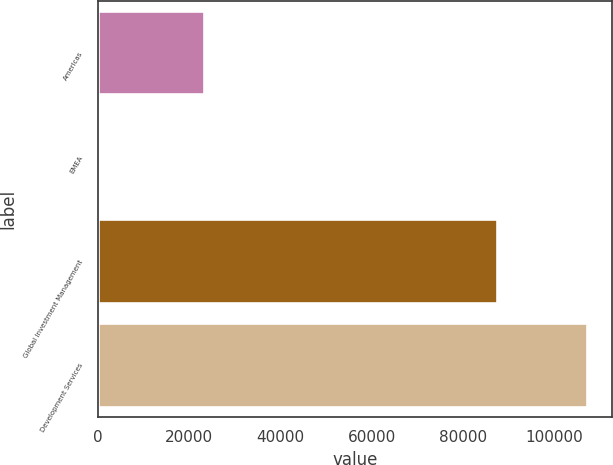Convert chart. <chart><loc_0><loc_0><loc_500><loc_500><bar_chart><fcel>Americas<fcel>EMEA<fcel>Global Investment Management<fcel>Development Services<nl><fcel>23318<fcel>422<fcel>87352<fcel>107188<nl></chart> 